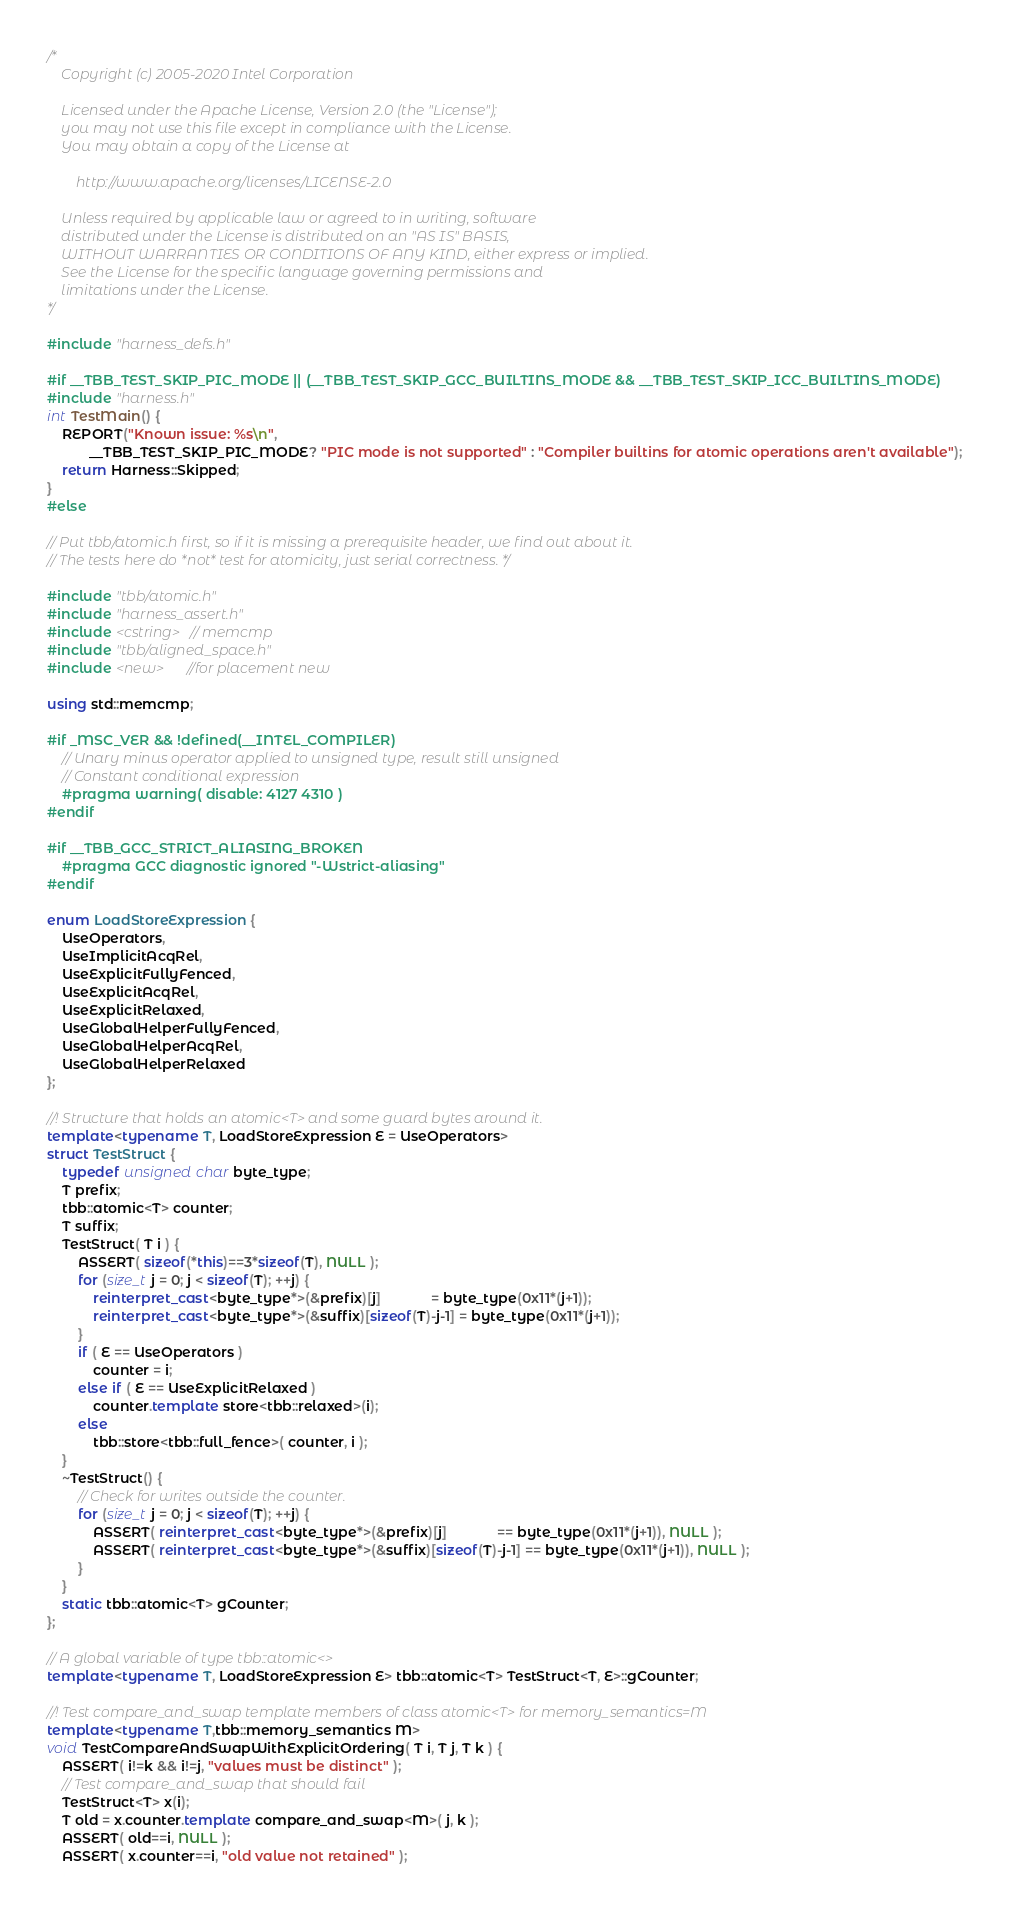Convert code to text. <code><loc_0><loc_0><loc_500><loc_500><_C++_>/*
    Copyright (c) 2005-2020 Intel Corporation

    Licensed under the Apache License, Version 2.0 (the "License");
    you may not use this file except in compliance with the License.
    You may obtain a copy of the License at

        http://www.apache.org/licenses/LICENSE-2.0

    Unless required by applicable law or agreed to in writing, software
    distributed under the License is distributed on an "AS IS" BASIS,
    WITHOUT WARRANTIES OR CONDITIONS OF ANY KIND, either express or implied.
    See the License for the specific language governing permissions and
    limitations under the License.
*/

#include "harness_defs.h"

#if __TBB_TEST_SKIP_PIC_MODE || (__TBB_TEST_SKIP_GCC_BUILTINS_MODE && __TBB_TEST_SKIP_ICC_BUILTINS_MODE)
#include "harness.h"
int TestMain() {
    REPORT("Known issue: %s\n",
           __TBB_TEST_SKIP_PIC_MODE? "PIC mode is not supported" : "Compiler builtins for atomic operations aren't available");
    return Harness::Skipped;
}
#else

// Put tbb/atomic.h first, so if it is missing a prerequisite header, we find out about it.
// The tests here do *not* test for atomicity, just serial correctness. */

#include "tbb/atomic.h"
#include "harness_assert.h"
#include <cstring>  // memcmp
#include "tbb/aligned_space.h"
#include <new>      //for placement new

using std::memcmp;

#if _MSC_VER && !defined(__INTEL_COMPILER)
    // Unary minus operator applied to unsigned type, result still unsigned
    // Constant conditional expression
    #pragma warning( disable: 4127 4310 )
#endif

#if __TBB_GCC_STRICT_ALIASING_BROKEN
    #pragma GCC diagnostic ignored "-Wstrict-aliasing"
#endif

enum LoadStoreExpression {
    UseOperators,
    UseImplicitAcqRel,
    UseExplicitFullyFenced,
    UseExplicitAcqRel,
    UseExplicitRelaxed,
    UseGlobalHelperFullyFenced,
    UseGlobalHelperAcqRel,
    UseGlobalHelperRelaxed
};

//! Structure that holds an atomic<T> and some guard bytes around it.
template<typename T, LoadStoreExpression E = UseOperators>
struct TestStruct {
    typedef unsigned char byte_type;
    T prefix;
    tbb::atomic<T> counter;
    T suffix;
    TestStruct( T i ) {
        ASSERT( sizeof(*this)==3*sizeof(T), NULL );
        for (size_t j = 0; j < sizeof(T); ++j) {
            reinterpret_cast<byte_type*>(&prefix)[j]             = byte_type(0x11*(j+1));
            reinterpret_cast<byte_type*>(&suffix)[sizeof(T)-j-1] = byte_type(0x11*(j+1));
        }
        if ( E == UseOperators )
            counter = i;
        else if ( E == UseExplicitRelaxed )
            counter.template store<tbb::relaxed>(i);
        else
            tbb::store<tbb::full_fence>( counter, i );
    }
    ~TestStruct() {
        // Check for writes outside the counter.
        for (size_t j = 0; j < sizeof(T); ++j) {
            ASSERT( reinterpret_cast<byte_type*>(&prefix)[j]             == byte_type(0x11*(j+1)), NULL );
            ASSERT( reinterpret_cast<byte_type*>(&suffix)[sizeof(T)-j-1] == byte_type(0x11*(j+1)), NULL );
        }
    }
    static tbb::atomic<T> gCounter;
};

// A global variable of type tbb::atomic<>
template<typename T, LoadStoreExpression E> tbb::atomic<T> TestStruct<T, E>::gCounter;

//! Test compare_and_swap template members of class atomic<T> for memory_semantics=M
template<typename T,tbb::memory_semantics M>
void TestCompareAndSwapWithExplicitOrdering( T i, T j, T k ) {
    ASSERT( i!=k && i!=j, "values must be distinct" );
    // Test compare_and_swap that should fail
    TestStruct<T> x(i);
    T old = x.counter.template compare_and_swap<M>( j, k );
    ASSERT( old==i, NULL );
    ASSERT( x.counter==i, "old value not retained" );</code> 